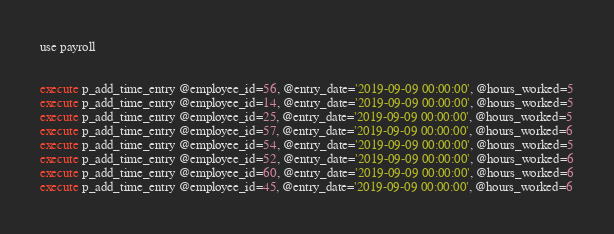<code> <loc_0><loc_0><loc_500><loc_500><_SQL_>use payroll


execute p_add_time_entry @employee_id=56, @entry_date='2019-09-09 00:00:00', @hours_worked=5
execute p_add_time_entry @employee_id=14, @entry_date='2019-09-09 00:00:00', @hours_worked=5
execute p_add_time_entry @employee_id=25, @entry_date='2019-09-09 00:00:00', @hours_worked=5
execute p_add_time_entry @employee_id=57, @entry_date='2019-09-09 00:00:00', @hours_worked=6
execute p_add_time_entry @employee_id=54, @entry_date='2019-09-09 00:00:00', @hours_worked=5
execute p_add_time_entry @employee_id=52, @entry_date='2019-09-09 00:00:00', @hours_worked=6
execute p_add_time_entry @employee_id=60, @entry_date='2019-09-09 00:00:00', @hours_worked=6
execute p_add_time_entry @employee_id=45, @entry_date='2019-09-09 00:00:00', @hours_worked=6

</code> 